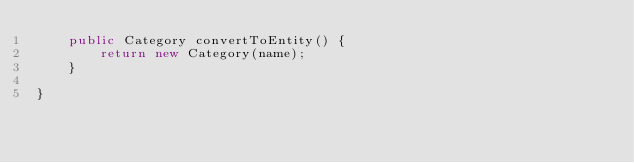<code> <loc_0><loc_0><loc_500><loc_500><_Java_>    public Category convertToEntity() {
        return new Category(name);
    }

}
</code> 